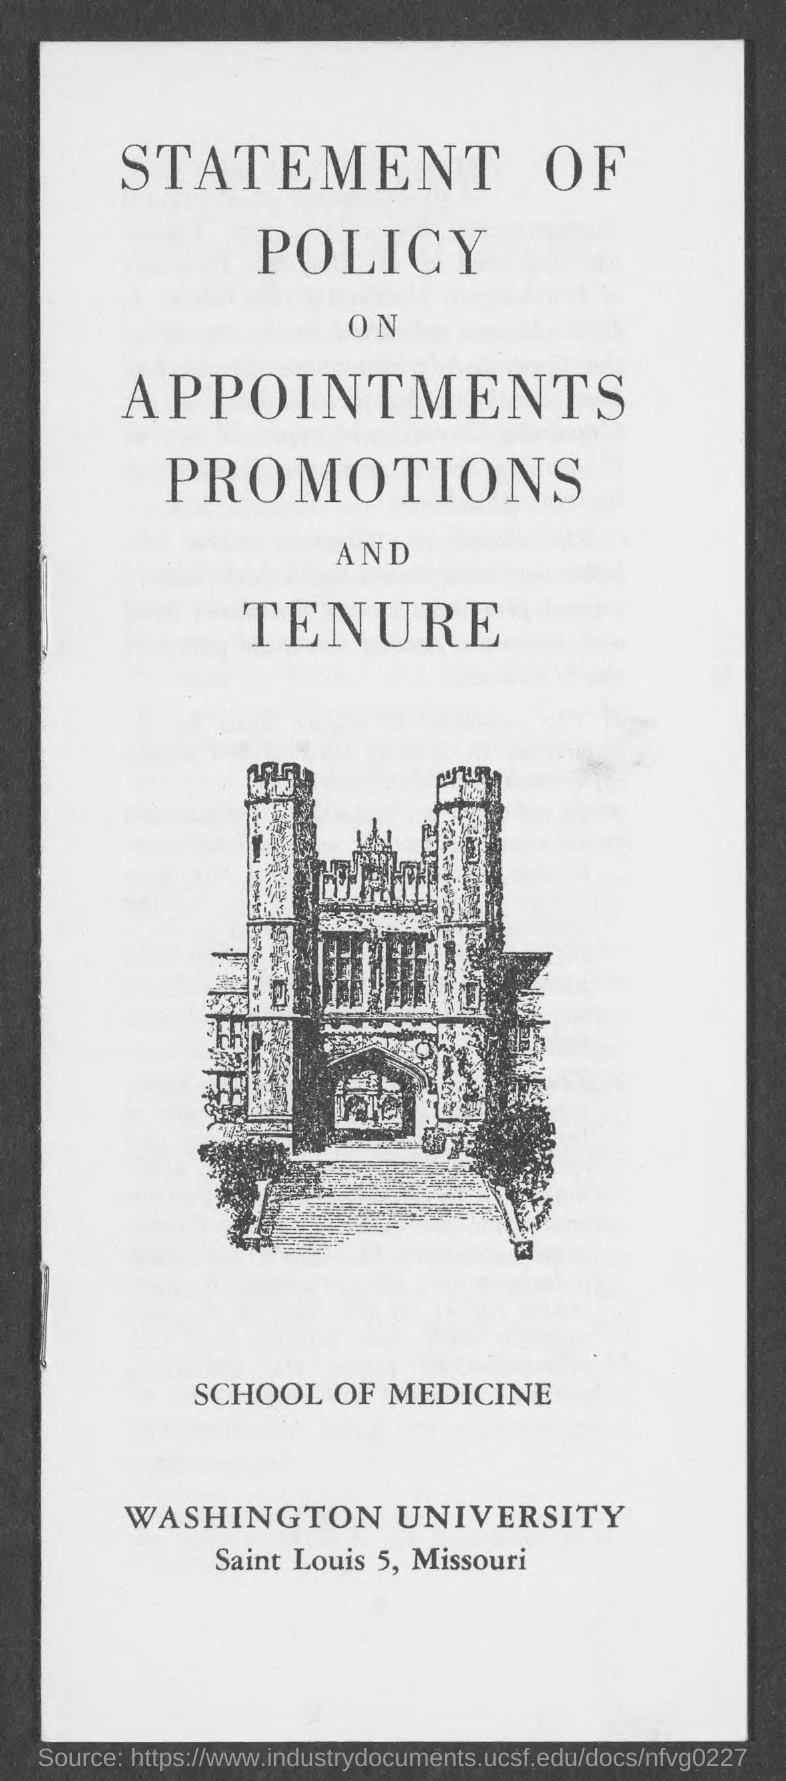Which University is mentioned in the document?
Make the answer very short. Washington university. 